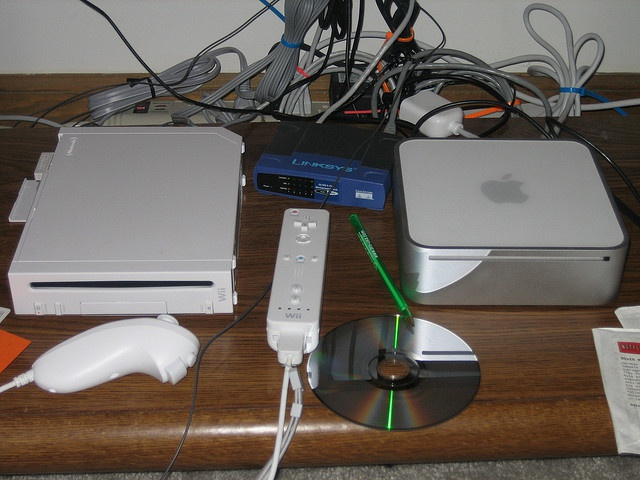Describe the objects in this image and their specific colors. I can see remote in gray, lightgray, darkgray, and maroon tones, remote in gray, darkgray, lightgray, and black tones, and apple in gray tones in this image. 